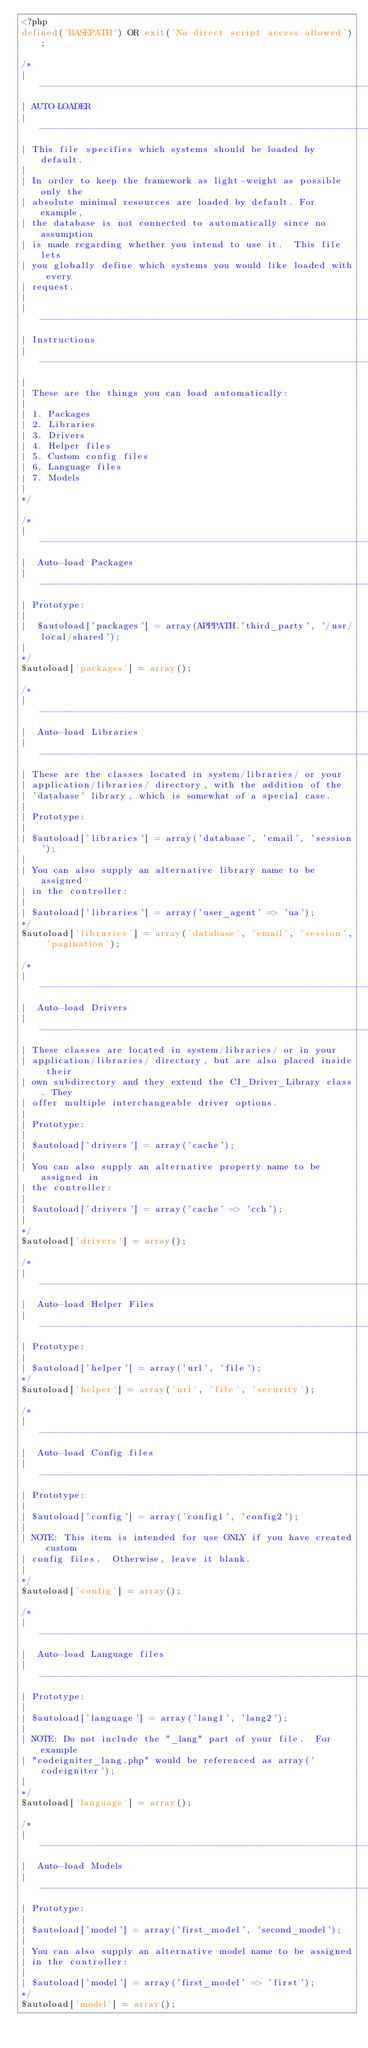Convert code to text. <code><loc_0><loc_0><loc_500><loc_500><_PHP_><?php
defined('BASEPATH') OR exit('No direct script access allowed');

/*
| -------------------------------------------------------------------
| AUTO-LOADER
| -------------------------------------------------------------------
| This file specifies which systems should be loaded by default.
|
| In order to keep the framework as light-weight as possible only the
| absolute minimal resources are loaded by default. For example,
| the database is not connected to automatically since no assumption
| is made regarding whether you intend to use it.  This file lets
| you globally define which systems you would like loaded with every
| request.
|
| -------------------------------------------------------------------
| Instructions
| -------------------------------------------------------------------
|
| These are the things you can load automatically:
|
| 1. Packages
| 2. Libraries
| 3. Drivers
| 4. Helper files
| 5. Custom config files
| 6. Language files
| 7. Models
|
*/

/*
| -------------------------------------------------------------------
|  Auto-load Packages
| -------------------------------------------------------------------
| Prototype:
|
|  $autoload['packages'] = array(APPPATH.'third_party', '/usr/local/shared');
|
*/
$autoload['packages'] = array();

/*
| -------------------------------------------------------------------
|  Auto-load Libraries
| -------------------------------------------------------------------
| These are the classes located in system/libraries/ or your
| application/libraries/ directory, with the addition of the
| 'database' library, which is somewhat of a special case.
|
| Prototype:
|
|	$autoload['libraries'] = array('database', 'email', 'session');
|
| You can also supply an alternative library name to be assigned
| in the controller:
|
|	$autoload['libraries'] = array('user_agent' => 'ua');
*/
$autoload['libraries'] = array('database', 'email', 'session', 'pagination');

/*
| -------------------------------------------------------------------
|  Auto-load Drivers
| -------------------------------------------------------------------
| These classes are located in system/libraries/ or in your
| application/libraries/ directory, but are also placed inside their
| own subdirectory and they extend the CI_Driver_Library class. They
| offer multiple interchangeable driver options.
|
| Prototype:
|
|	$autoload['drivers'] = array('cache');
|
| You can also supply an alternative property name to be assigned in
| the controller:
|
|	$autoload['drivers'] = array('cache' => 'cch');
|
*/
$autoload['drivers'] = array();

/*
| -------------------------------------------------------------------
|  Auto-load Helper Files
| -------------------------------------------------------------------
| Prototype:
|
|	$autoload['helper'] = array('url', 'file');
*/
$autoload['helper'] = array('url', 'file', 'security');

/*
| -------------------------------------------------------------------
|  Auto-load Config files
| -------------------------------------------------------------------
| Prototype:
|
|	$autoload['config'] = array('config1', 'config2');
|
| NOTE: This item is intended for use ONLY if you have created custom
| config files.  Otherwise, leave it blank.
|
*/
$autoload['config'] = array();

/*
| -------------------------------------------------------------------
|  Auto-load Language files
| -------------------------------------------------------------------
| Prototype:
|
|	$autoload['language'] = array('lang1', 'lang2');
|
| NOTE: Do not include the "_lang" part of your file.  For example
| "codeigniter_lang.php" would be referenced as array('codeigniter');
|
*/
$autoload['language'] = array();

/*
| -------------------------------------------------------------------
|  Auto-load Models
| -------------------------------------------------------------------
| Prototype:
|
|	$autoload['model'] = array('first_model', 'second_model');
|
| You can also supply an alternative model name to be assigned
| in the controller:
|
|	$autoload['model'] = array('first_model' => 'first');
*/
$autoload['model'] = array();
</code> 